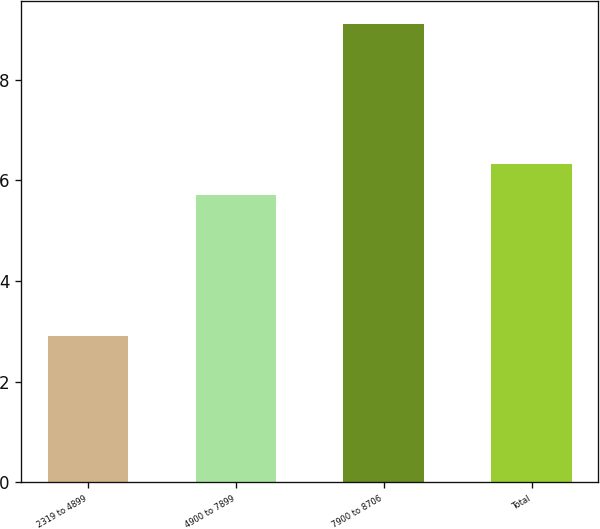<chart> <loc_0><loc_0><loc_500><loc_500><bar_chart><fcel>2319 to 4899<fcel>4900 to 7899<fcel>7900 to 8706<fcel>Total<nl><fcel>2.9<fcel>5.7<fcel>9.1<fcel>6.32<nl></chart> 